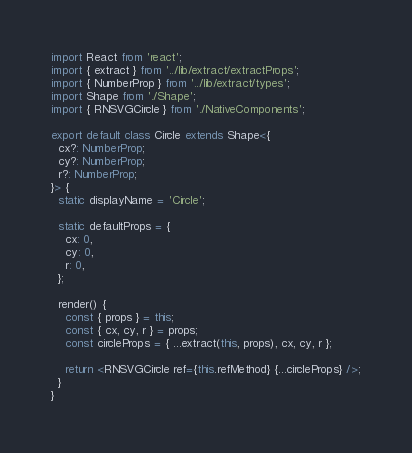Convert code to text. <code><loc_0><loc_0><loc_500><loc_500><_TypeScript_>import React from 'react';
import { extract } from '../lib/extract/extractProps';
import { NumberProp } from '../lib/extract/types';
import Shape from './Shape';
import { RNSVGCircle } from './NativeComponents';

export default class Circle extends Shape<{
  cx?: NumberProp;
  cy?: NumberProp;
  r?: NumberProp;
}> {
  static displayName = 'Circle';

  static defaultProps = {
    cx: 0,
    cy: 0,
    r: 0,
  };

  render() {
    const { props } = this;
    const { cx, cy, r } = props;
    const circleProps = { ...extract(this, props), cx, cy, r };

    return <RNSVGCircle ref={this.refMethod} {...circleProps} />;
  }
}
</code> 